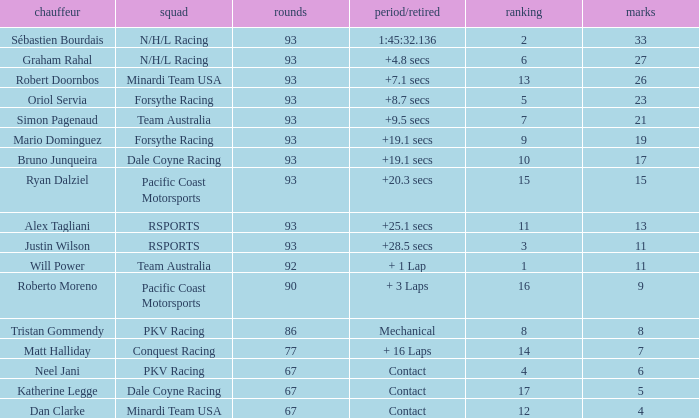What is the grid for the Minardi Team USA with laps smaller than 90? 12.0. Can you give me this table as a dict? {'header': ['chauffeur', 'squad', 'rounds', 'period/retired', 'ranking', 'marks'], 'rows': [['Sébastien Bourdais', 'N/H/L Racing', '93', '1:45:32.136', '2', '33'], ['Graham Rahal', 'N/H/L Racing', '93', '+4.8 secs', '6', '27'], ['Robert Doornbos', 'Minardi Team USA', '93', '+7.1 secs', '13', '26'], ['Oriol Servia', 'Forsythe Racing', '93', '+8.7 secs', '5', '23'], ['Simon Pagenaud', 'Team Australia', '93', '+9.5 secs', '7', '21'], ['Mario Dominguez', 'Forsythe Racing', '93', '+19.1 secs', '9', '19'], ['Bruno Junqueira', 'Dale Coyne Racing', '93', '+19.1 secs', '10', '17'], ['Ryan Dalziel', 'Pacific Coast Motorsports', '93', '+20.3 secs', '15', '15'], ['Alex Tagliani', 'RSPORTS', '93', '+25.1 secs', '11', '13'], ['Justin Wilson', 'RSPORTS', '93', '+28.5 secs', '3', '11'], ['Will Power', 'Team Australia', '92', '+ 1 Lap', '1', '11'], ['Roberto Moreno', 'Pacific Coast Motorsports', '90', '+ 3 Laps', '16', '9'], ['Tristan Gommendy', 'PKV Racing', '86', 'Mechanical', '8', '8'], ['Matt Halliday', 'Conquest Racing', '77', '+ 16 Laps', '14', '7'], ['Neel Jani', 'PKV Racing', '67', 'Contact', '4', '6'], ['Katherine Legge', 'Dale Coyne Racing', '67', 'Contact', '17', '5'], ['Dan Clarke', 'Minardi Team USA', '67', 'Contact', '12', '4']]} 